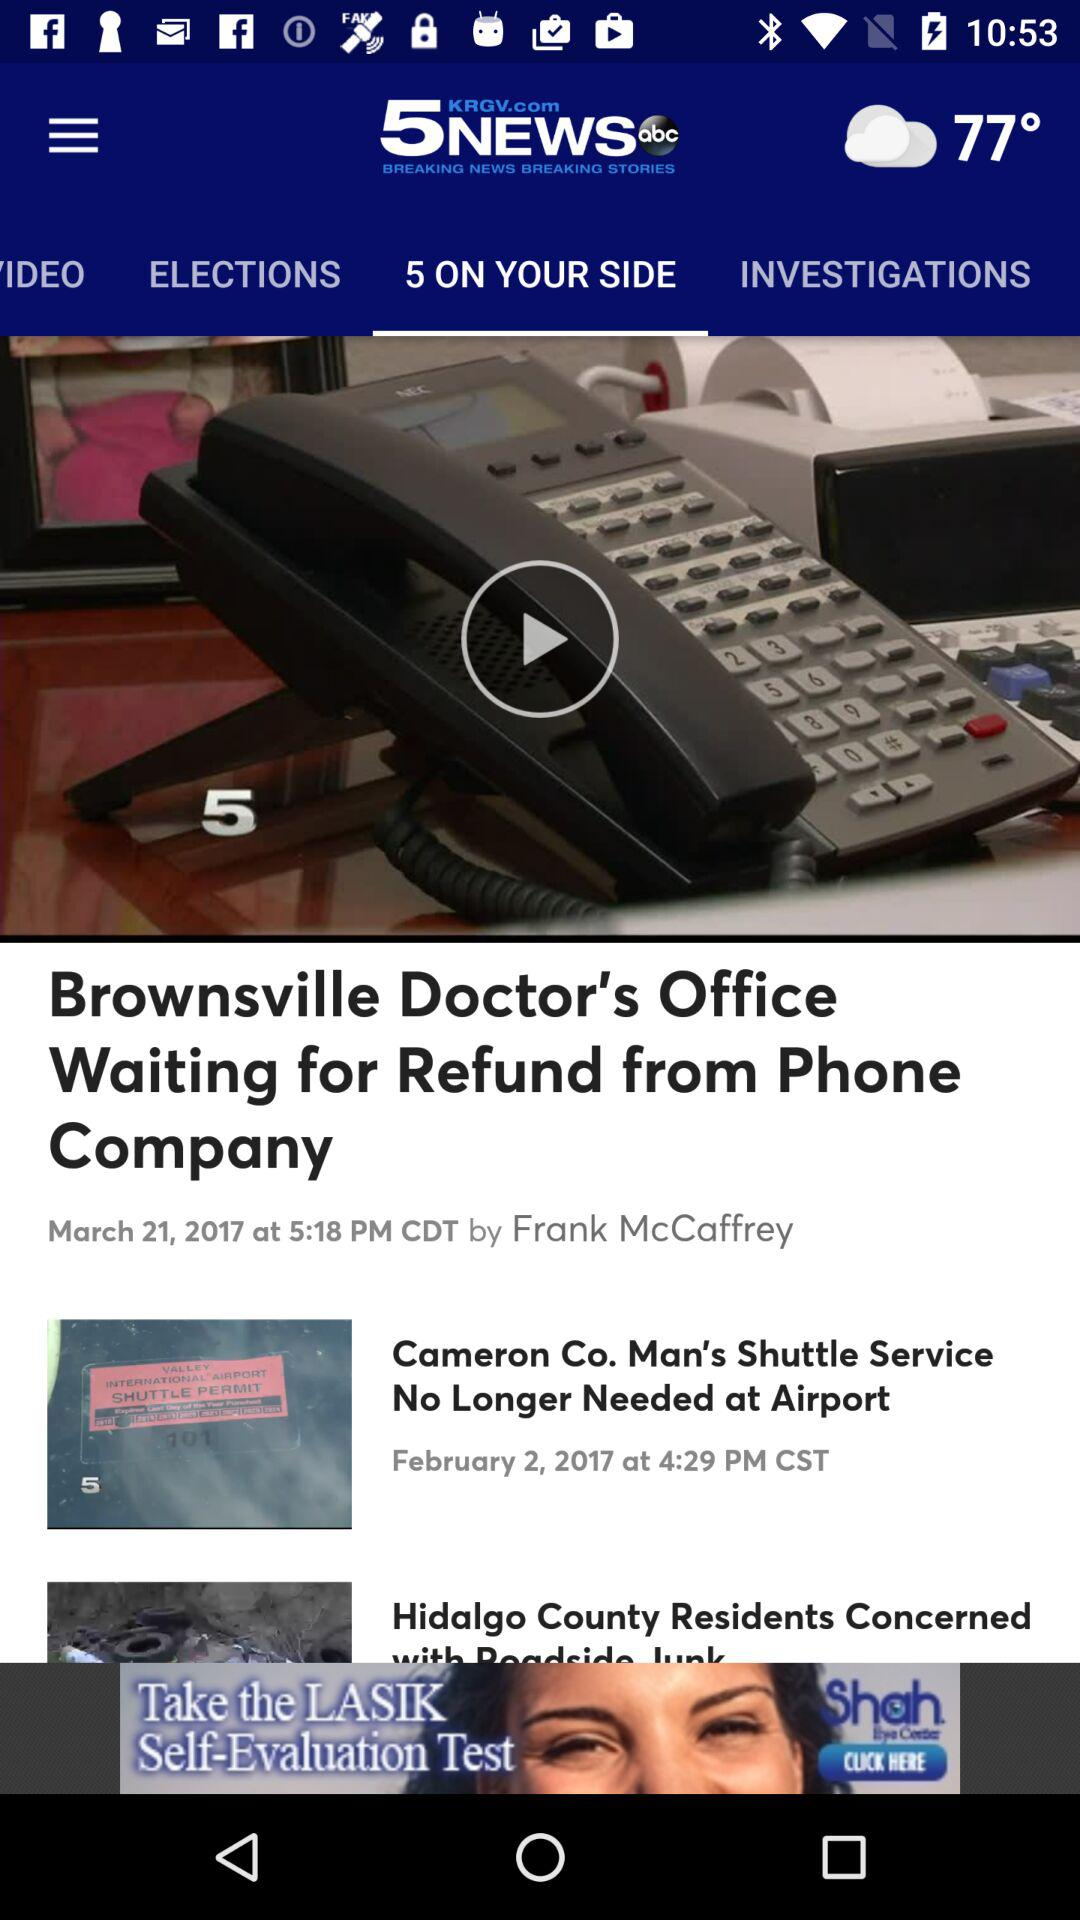What is the temperature? The temperature is 77 degrees. 